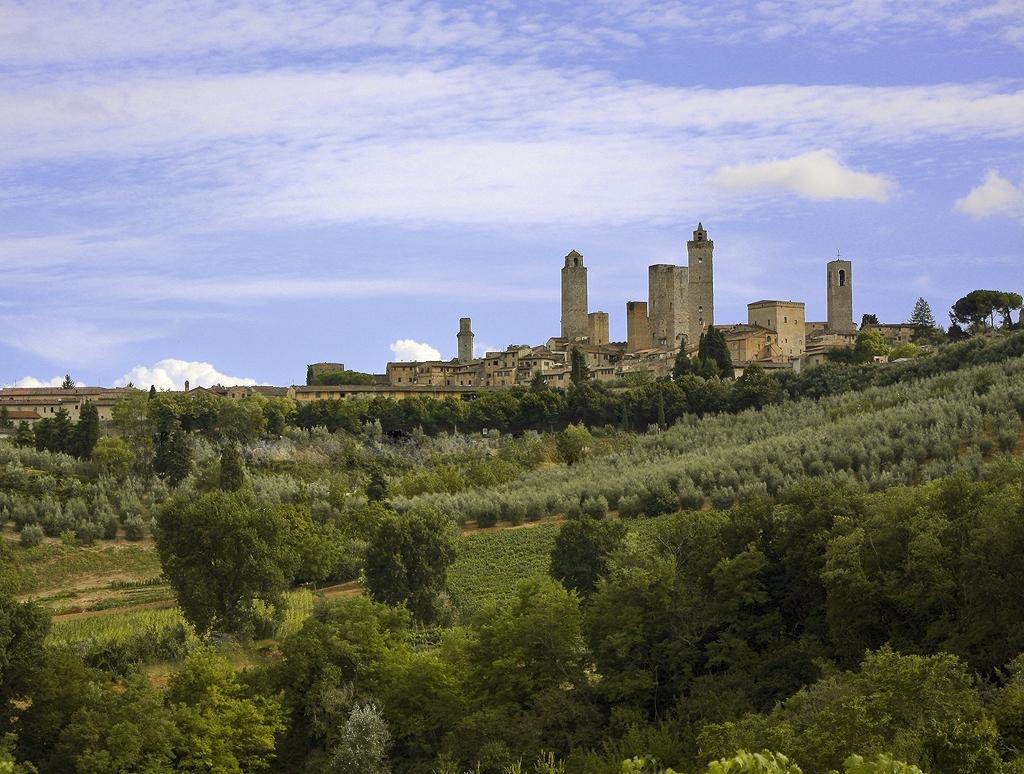Where was the image taken? The image was taken outdoors. What can be seen in the foreground of the image? There are trees in the foreground of the image. What can be seen in the background of the image? There are buildings in the background of the image. What is visible in the sky in the image? The sky is visible in the image, and clouds are present. What song is being sung by the trees in the image? There is no indication in the image that the trees are singing a song, as trees do not have the ability to sing. 